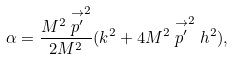Convert formula to latex. <formula><loc_0><loc_0><loc_500><loc_500>\alpha = \frac { M ^ { 2 } \stackrel { \rightarrow } { p ^ { \prime } } ^ { 2 } } { 2 M ^ { 2 } } ( k ^ { 2 } + 4 M ^ { 2 } \stackrel { \rightarrow } { p ^ { \prime } } ^ { 2 } h ^ { 2 } ) ,</formula> 